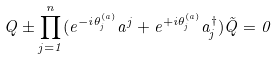<formula> <loc_0><loc_0><loc_500><loc_500>Q \pm \prod _ { j = 1 } ^ { n } ( e ^ { - i \theta _ { j } ^ { ( a ) } } a ^ { j } + e ^ { + i \theta _ { j } ^ { ( a ) } } a _ { j } ^ { \dagger } ) \tilde { Q } = 0</formula> 